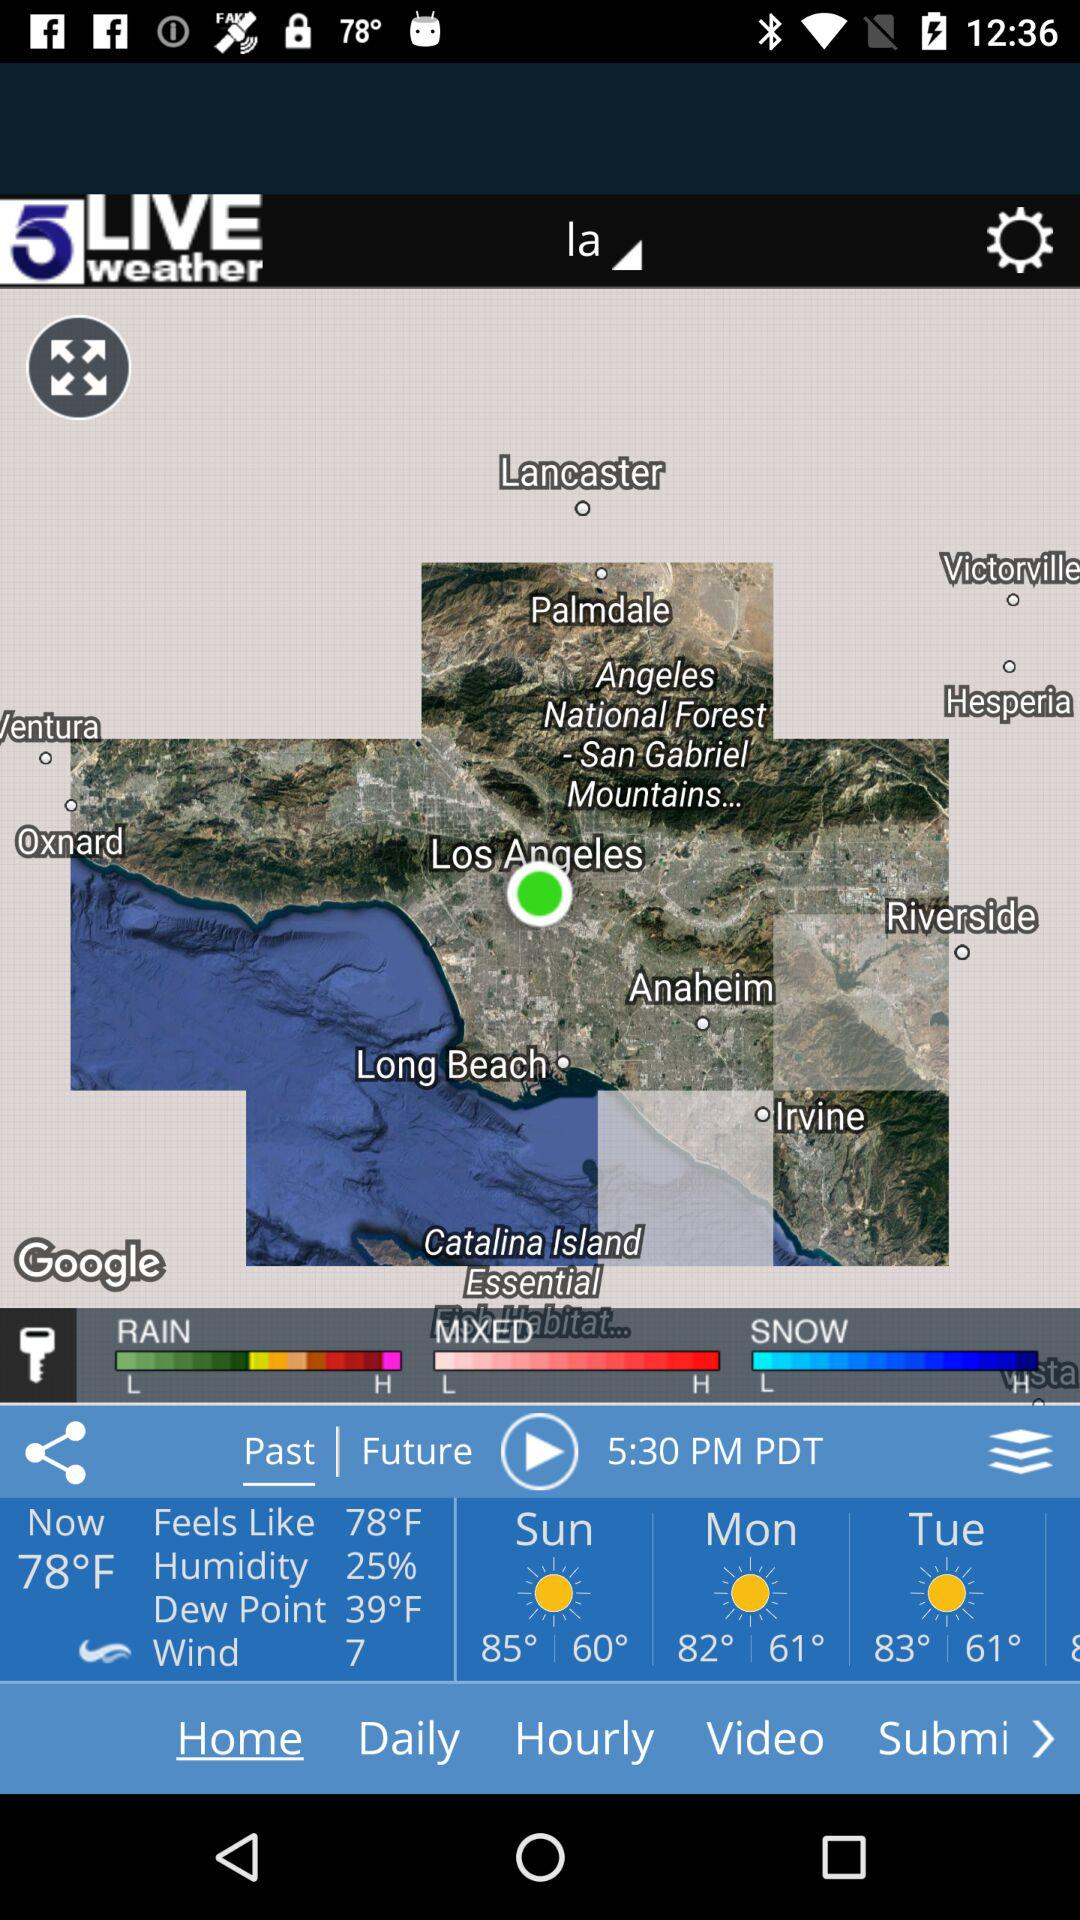How many days does the weather forecast show?
Answer the question using a single word or phrase. 3 